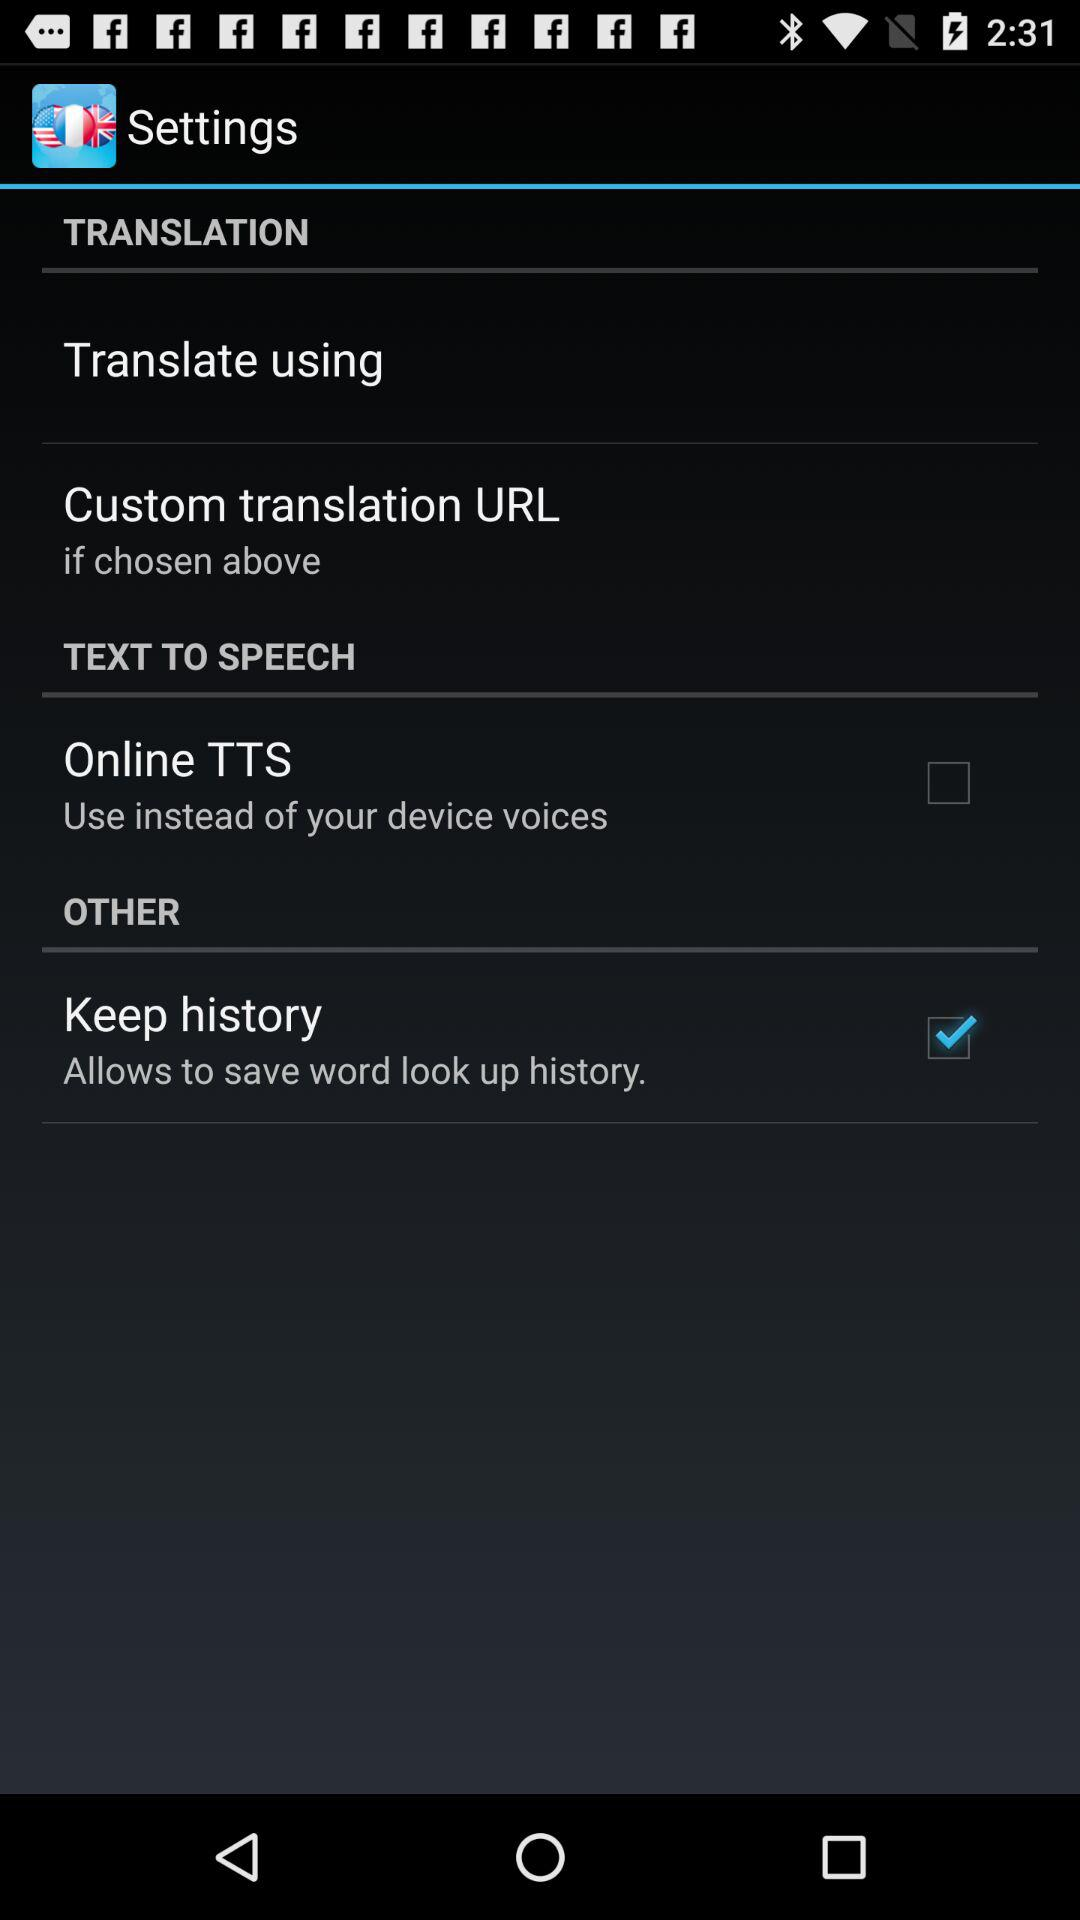What is the status of "Keep history"? The status is "on". 